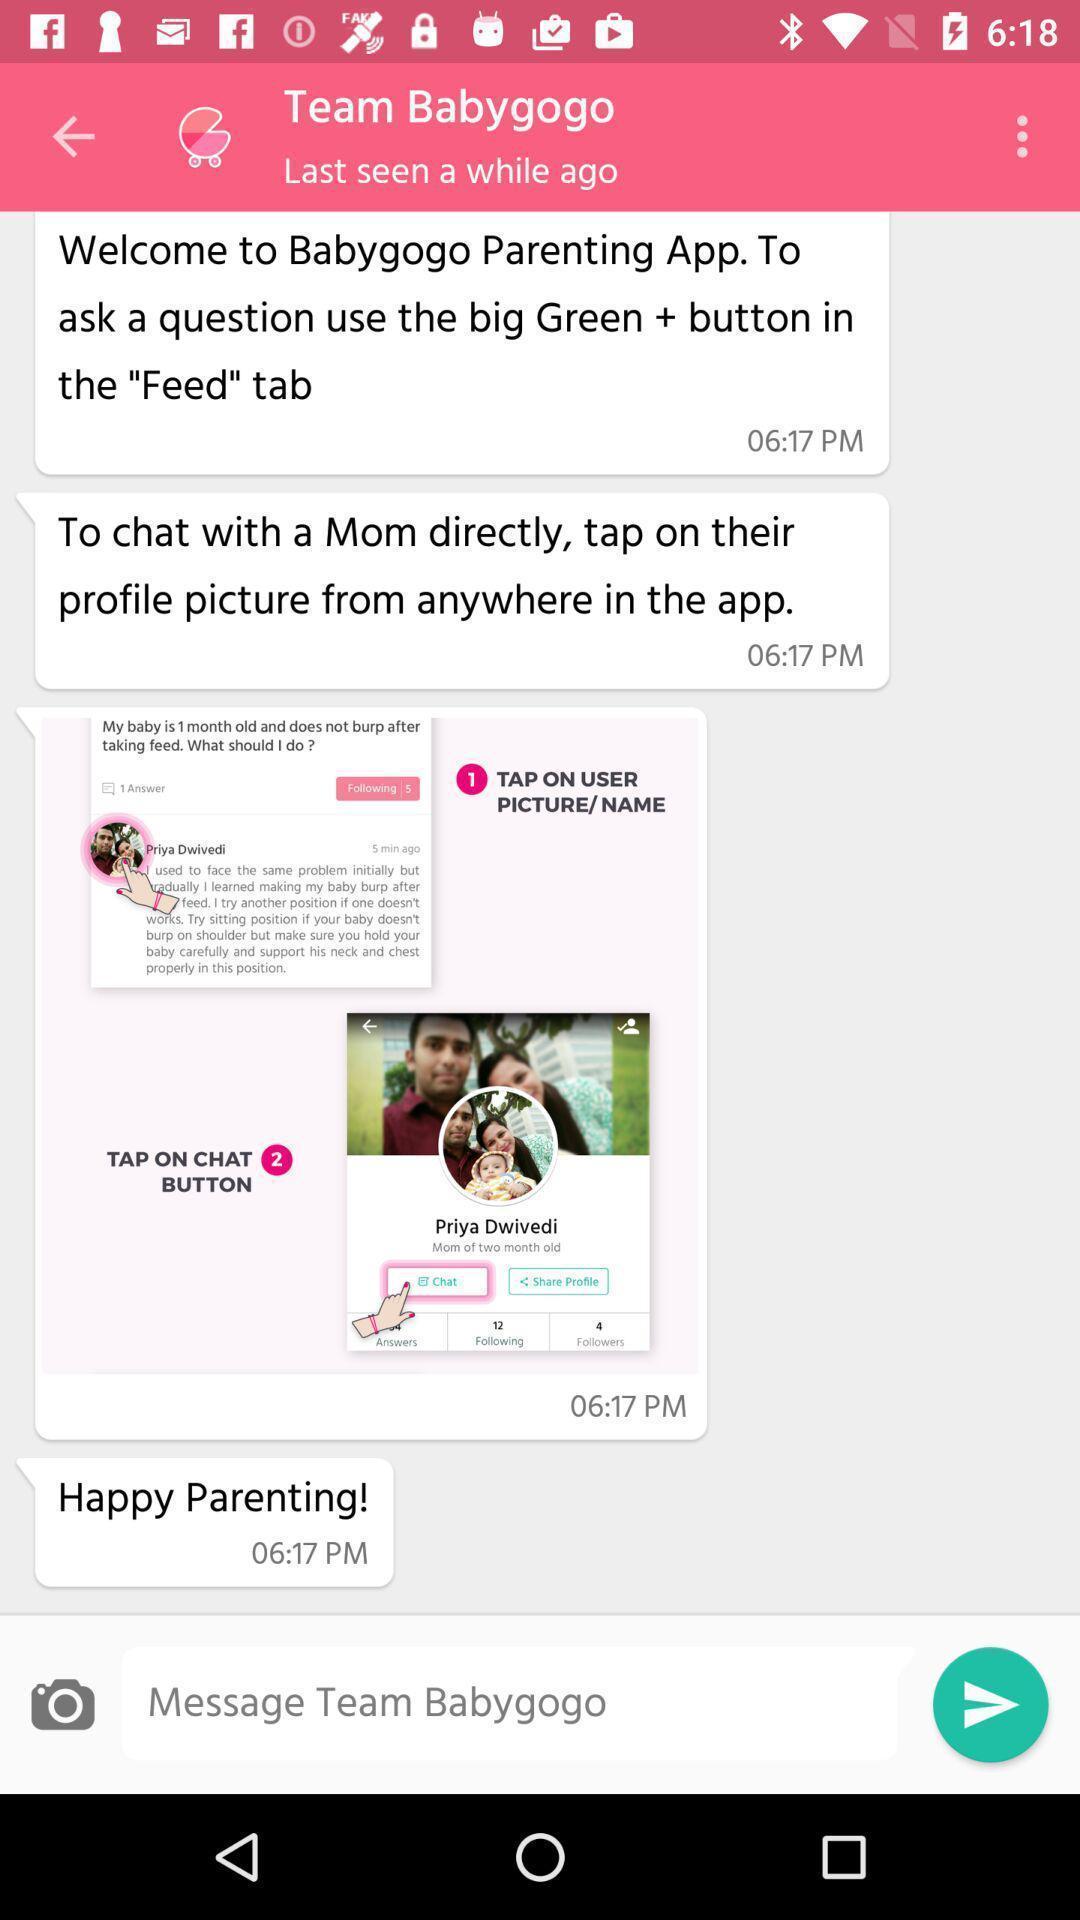Give me a narrative description of this picture. Page showing a conversation on an app. 